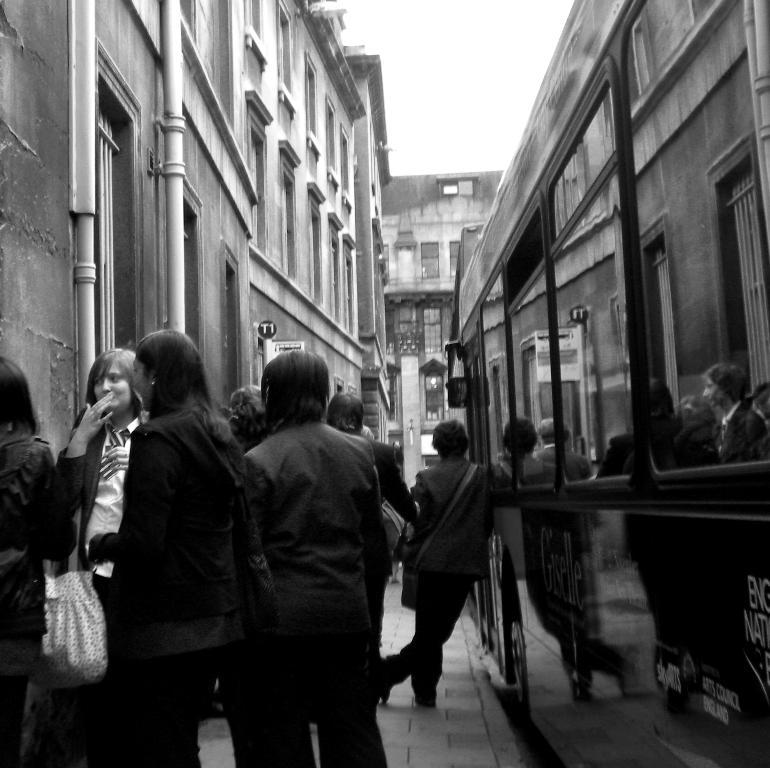What is the color scheme of the image? The image is black and white. What can be seen in the image besides the color scheme? There are people, a vehicle, and buildings in the image. What type of lace is being used to decorate the buildings in the image? There is no lace present in the image; it is a black and white image featuring people, a vehicle, and buildings. 